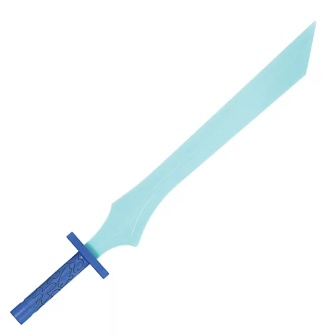What kind of enemy would this sword be most effective against? Given its magical design and light blue blade, this sword would be exceptionally effective against ethereal enemies, such as ghosts or shadow creatures. The mystical energies imbued within the blade can dispel dark magic and sever the bonds that bind such entities to the physical realm, making it an essential tool for any warrior facing otherworldly threats. 